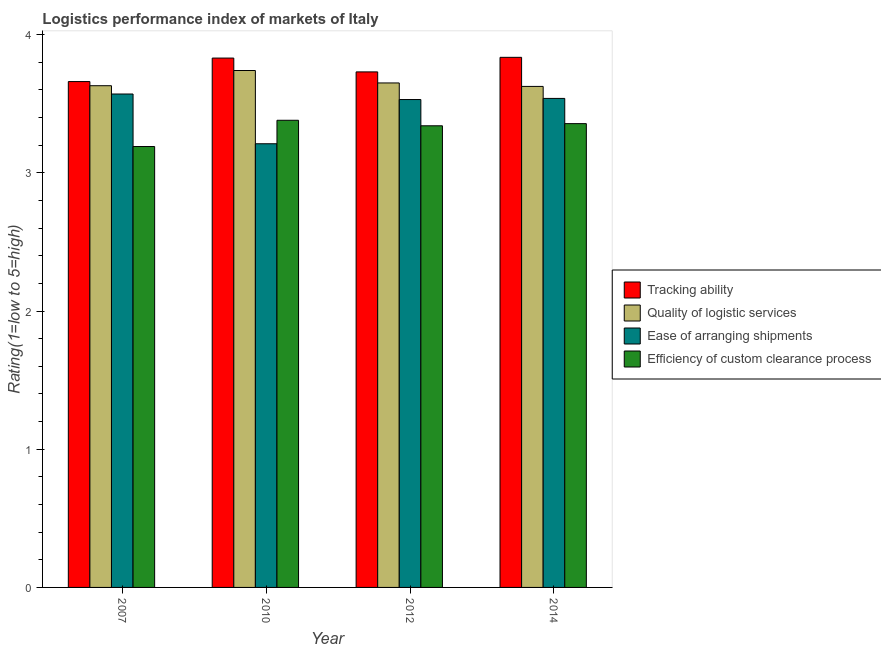Are the number of bars on each tick of the X-axis equal?
Offer a terse response. Yes. What is the lpi rating of efficiency of custom clearance process in 2010?
Keep it short and to the point. 3.38. Across all years, what is the maximum lpi rating of efficiency of custom clearance process?
Provide a short and direct response. 3.38. Across all years, what is the minimum lpi rating of efficiency of custom clearance process?
Offer a very short reply. 3.19. In which year was the lpi rating of ease of arranging shipments maximum?
Keep it short and to the point. 2007. What is the total lpi rating of quality of logistic services in the graph?
Give a very brief answer. 14.64. What is the difference between the lpi rating of quality of logistic services in 2007 and that in 2012?
Your answer should be compact. -0.02. What is the difference between the lpi rating of tracking ability in 2010 and the lpi rating of ease of arranging shipments in 2007?
Provide a succinct answer. 0.17. What is the average lpi rating of ease of arranging shipments per year?
Offer a very short reply. 3.46. In the year 2012, what is the difference between the lpi rating of quality of logistic services and lpi rating of ease of arranging shipments?
Offer a very short reply. 0. What is the ratio of the lpi rating of ease of arranging shipments in 2012 to that in 2014?
Your response must be concise. 1. Is the lpi rating of efficiency of custom clearance process in 2007 less than that in 2012?
Make the answer very short. Yes. What is the difference between the highest and the second highest lpi rating of ease of arranging shipments?
Give a very brief answer. 0.03. What is the difference between the highest and the lowest lpi rating of quality of logistic services?
Your answer should be compact. 0.12. In how many years, is the lpi rating of ease of arranging shipments greater than the average lpi rating of ease of arranging shipments taken over all years?
Give a very brief answer. 3. Is the sum of the lpi rating of ease of arranging shipments in 2007 and 2014 greater than the maximum lpi rating of tracking ability across all years?
Your response must be concise. Yes. What does the 3rd bar from the left in 2007 represents?
Give a very brief answer. Ease of arranging shipments. What does the 4th bar from the right in 2014 represents?
Ensure brevity in your answer.  Tracking ability. Is it the case that in every year, the sum of the lpi rating of tracking ability and lpi rating of quality of logistic services is greater than the lpi rating of ease of arranging shipments?
Keep it short and to the point. Yes. How many bars are there?
Your response must be concise. 16. Are the values on the major ticks of Y-axis written in scientific E-notation?
Give a very brief answer. No. Does the graph contain grids?
Offer a terse response. No. How many legend labels are there?
Your response must be concise. 4. What is the title of the graph?
Provide a succinct answer. Logistics performance index of markets of Italy. What is the label or title of the X-axis?
Your answer should be compact. Year. What is the label or title of the Y-axis?
Offer a very short reply. Rating(1=low to 5=high). What is the Rating(1=low to 5=high) in Tracking ability in 2007?
Give a very brief answer. 3.66. What is the Rating(1=low to 5=high) of Quality of logistic services in 2007?
Offer a very short reply. 3.63. What is the Rating(1=low to 5=high) of Ease of arranging shipments in 2007?
Your response must be concise. 3.57. What is the Rating(1=low to 5=high) of Efficiency of custom clearance process in 2007?
Keep it short and to the point. 3.19. What is the Rating(1=low to 5=high) in Tracking ability in 2010?
Give a very brief answer. 3.83. What is the Rating(1=low to 5=high) of Quality of logistic services in 2010?
Make the answer very short. 3.74. What is the Rating(1=low to 5=high) of Ease of arranging shipments in 2010?
Ensure brevity in your answer.  3.21. What is the Rating(1=low to 5=high) of Efficiency of custom clearance process in 2010?
Keep it short and to the point. 3.38. What is the Rating(1=low to 5=high) of Tracking ability in 2012?
Offer a terse response. 3.73. What is the Rating(1=low to 5=high) of Quality of logistic services in 2012?
Provide a succinct answer. 3.65. What is the Rating(1=low to 5=high) in Ease of arranging shipments in 2012?
Your answer should be very brief. 3.53. What is the Rating(1=low to 5=high) of Efficiency of custom clearance process in 2012?
Offer a very short reply. 3.34. What is the Rating(1=low to 5=high) in Tracking ability in 2014?
Your answer should be compact. 3.84. What is the Rating(1=low to 5=high) of Quality of logistic services in 2014?
Keep it short and to the point. 3.62. What is the Rating(1=low to 5=high) of Ease of arranging shipments in 2014?
Give a very brief answer. 3.54. What is the Rating(1=low to 5=high) in Efficiency of custom clearance process in 2014?
Give a very brief answer. 3.36. Across all years, what is the maximum Rating(1=low to 5=high) in Tracking ability?
Provide a succinct answer. 3.84. Across all years, what is the maximum Rating(1=low to 5=high) in Quality of logistic services?
Your response must be concise. 3.74. Across all years, what is the maximum Rating(1=low to 5=high) of Ease of arranging shipments?
Ensure brevity in your answer.  3.57. Across all years, what is the maximum Rating(1=low to 5=high) in Efficiency of custom clearance process?
Your answer should be compact. 3.38. Across all years, what is the minimum Rating(1=low to 5=high) of Tracking ability?
Provide a succinct answer. 3.66. Across all years, what is the minimum Rating(1=low to 5=high) in Quality of logistic services?
Your answer should be compact. 3.62. Across all years, what is the minimum Rating(1=low to 5=high) in Ease of arranging shipments?
Offer a very short reply. 3.21. Across all years, what is the minimum Rating(1=low to 5=high) of Efficiency of custom clearance process?
Your response must be concise. 3.19. What is the total Rating(1=low to 5=high) of Tracking ability in the graph?
Ensure brevity in your answer.  15.06. What is the total Rating(1=low to 5=high) of Quality of logistic services in the graph?
Keep it short and to the point. 14.64. What is the total Rating(1=low to 5=high) of Ease of arranging shipments in the graph?
Your answer should be very brief. 13.85. What is the total Rating(1=low to 5=high) of Efficiency of custom clearance process in the graph?
Provide a succinct answer. 13.27. What is the difference between the Rating(1=low to 5=high) in Tracking ability in 2007 and that in 2010?
Ensure brevity in your answer.  -0.17. What is the difference between the Rating(1=low to 5=high) in Quality of logistic services in 2007 and that in 2010?
Provide a succinct answer. -0.11. What is the difference between the Rating(1=low to 5=high) in Ease of arranging shipments in 2007 and that in 2010?
Your answer should be compact. 0.36. What is the difference between the Rating(1=low to 5=high) in Efficiency of custom clearance process in 2007 and that in 2010?
Your answer should be compact. -0.19. What is the difference between the Rating(1=low to 5=high) in Tracking ability in 2007 and that in 2012?
Your response must be concise. -0.07. What is the difference between the Rating(1=low to 5=high) of Quality of logistic services in 2007 and that in 2012?
Ensure brevity in your answer.  -0.02. What is the difference between the Rating(1=low to 5=high) in Ease of arranging shipments in 2007 and that in 2012?
Keep it short and to the point. 0.04. What is the difference between the Rating(1=low to 5=high) of Tracking ability in 2007 and that in 2014?
Make the answer very short. -0.18. What is the difference between the Rating(1=low to 5=high) of Quality of logistic services in 2007 and that in 2014?
Your answer should be very brief. 0.01. What is the difference between the Rating(1=low to 5=high) of Ease of arranging shipments in 2007 and that in 2014?
Give a very brief answer. 0.03. What is the difference between the Rating(1=low to 5=high) in Efficiency of custom clearance process in 2007 and that in 2014?
Offer a very short reply. -0.17. What is the difference between the Rating(1=low to 5=high) of Tracking ability in 2010 and that in 2012?
Offer a terse response. 0.1. What is the difference between the Rating(1=low to 5=high) of Quality of logistic services in 2010 and that in 2012?
Your answer should be compact. 0.09. What is the difference between the Rating(1=low to 5=high) of Ease of arranging shipments in 2010 and that in 2012?
Make the answer very short. -0.32. What is the difference between the Rating(1=low to 5=high) in Tracking ability in 2010 and that in 2014?
Give a very brief answer. -0.01. What is the difference between the Rating(1=low to 5=high) of Quality of logistic services in 2010 and that in 2014?
Offer a terse response. 0.12. What is the difference between the Rating(1=low to 5=high) in Ease of arranging shipments in 2010 and that in 2014?
Give a very brief answer. -0.33. What is the difference between the Rating(1=low to 5=high) in Efficiency of custom clearance process in 2010 and that in 2014?
Your answer should be compact. 0.02. What is the difference between the Rating(1=low to 5=high) in Tracking ability in 2012 and that in 2014?
Offer a very short reply. -0.11. What is the difference between the Rating(1=low to 5=high) of Quality of logistic services in 2012 and that in 2014?
Your response must be concise. 0.03. What is the difference between the Rating(1=low to 5=high) in Ease of arranging shipments in 2012 and that in 2014?
Make the answer very short. -0.01. What is the difference between the Rating(1=low to 5=high) of Efficiency of custom clearance process in 2012 and that in 2014?
Give a very brief answer. -0.02. What is the difference between the Rating(1=low to 5=high) in Tracking ability in 2007 and the Rating(1=low to 5=high) in Quality of logistic services in 2010?
Your response must be concise. -0.08. What is the difference between the Rating(1=low to 5=high) of Tracking ability in 2007 and the Rating(1=low to 5=high) of Ease of arranging shipments in 2010?
Your answer should be compact. 0.45. What is the difference between the Rating(1=low to 5=high) in Tracking ability in 2007 and the Rating(1=low to 5=high) in Efficiency of custom clearance process in 2010?
Provide a succinct answer. 0.28. What is the difference between the Rating(1=low to 5=high) of Quality of logistic services in 2007 and the Rating(1=low to 5=high) of Ease of arranging shipments in 2010?
Make the answer very short. 0.42. What is the difference between the Rating(1=low to 5=high) of Quality of logistic services in 2007 and the Rating(1=low to 5=high) of Efficiency of custom clearance process in 2010?
Give a very brief answer. 0.25. What is the difference between the Rating(1=low to 5=high) of Ease of arranging shipments in 2007 and the Rating(1=low to 5=high) of Efficiency of custom clearance process in 2010?
Your answer should be compact. 0.19. What is the difference between the Rating(1=low to 5=high) in Tracking ability in 2007 and the Rating(1=low to 5=high) in Ease of arranging shipments in 2012?
Provide a short and direct response. 0.13. What is the difference between the Rating(1=low to 5=high) of Tracking ability in 2007 and the Rating(1=low to 5=high) of Efficiency of custom clearance process in 2012?
Offer a very short reply. 0.32. What is the difference between the Rating(1=low to 5=high) in Quality of logistic services in 2007 and the Rating(1=low to 5=high) in Ease of arranging shipments in 2012?
Ensure brevity in your answer.  0.1. What is the difference between the Rating(1=low to 5=high) of Quality of logistic services in 2007 and the Rating(1=low to 5=high) of Efficiency of custom clearance process in 2012?
Ensure brevity in your answer.  0.29. What is the difference between the Rating(1=low to 5=high) of Ease of arranging shipments in 2007 and the Rating(1=low to 5=high) of Efficiency of custom clearance process in 2012?
Make the answer very short. 0.23. What is the difference between the Rating(1=low to 5=high) in Tracking ability in 2007 and the Rating(1=low to 5=high) in Quality of logistic services in 2014?
Your response must be concise. 0.04. What is the difference between the Rating(1=low to 5=high) of Tracking ability in 2007 and the Rating(1=low to 5=high) of Ease of arranging shipments in 2014?
Offer a terse response. 0.12. What is the difference between the Rating(1=low to 5=high) in Tracking ability in 2007 and the Rating(1=low to 5=high) in Efficiency of custom clearance process in 2014?
Provide a short and direct response. 0.3. What is the difference between the Rating(1=low to 5=high) of Quality of logistic services in 2007 and the Rating(1=low to 5=high) of Ease of arranging shipments in 2014?
Keep it short and to the point. 0.09. What is the difference between the Rating(1=low to 5=high) of Quality of logistic services in 2007 and the Rating(1=low to 5=high) of Efficiency of custom clearance process in 2014?
Keep it short and to the point. 0.27. What is the difference between the Rating(1=low to 5=high) in Ease of arranging shipments in 2007 and the Rating(1=low to 5=high) in Efficiency of custom clearance process in 2014?
Your response must be concise. 0.21. What is the difference between the Rating(1=low to 5=high) in Tracking ability in 2010 and the Rating(1=low to 5=high) in Quality of logistic services in 2012?
Offer a terse response. 0.18. What is the difference between the Rating(1=low to 5=high) in Tracking ability in 2010 and the Rating(1=low to 5=high) in Efficiency of custom clearance process in 2012?
Give a very brief answer. 0.49. What is the difference between the Rating(1=low to 5=high) of Quality of logistic services in 2010 and the Rating(1=low to 5=high) of Ease of arranging shipments in 2012?
Make the answer very short. 0.21. What is the difference between the Rating(1=low to 5=high) in Ease of arranging shipments in 2010 and the Rating(1=low to 5=high) in Efficiency of custom clearance process in 2012?
Your answer should be very brief. -0.13. What is the difference between the Rating(1=low to 5=high) in Tracking ability in 2010 and the Rating(1=low to 5=high) in Quality of logistic services in 2014?
Offer a terse response. 0.2. What is the difference between the Rating(1=low to 5=high) in Tracking ability in 2010 and the Rating(1=low to 5=high) in Ease of arranging shipments in 2014?
Your response must be concise. 0.29. What is the difference between the Rating(1=low to 5=high) of Tracking ability in 2010 and the Rating(1=low to 5=high) of Efficiency of custom clearance process in 2014?
Your answer should be compact. 0.47. What is the difference between the Rating(1=low to 5=high) in Quality of logistic services in 2010 and the Rating(1=low to 5=high) in Ease of arranging shipments in 2014?
Your response must be concise. 0.2. What is the difference between the Rating(1=low to 5=high) of Quality of logistic services in 2010 and the Rating(1=low to 5=high) of Efficiency of custom clearance process in 2014?
Your answer should be compact. 0.38. What is the difference between the Rating(1=low to 5=high) in Ease of arranging shipments in 2010 and the Rating(1=low to 5=high) in Efficiency of custom clearance process in 2014?
Your response must be concise. -0.15. What is the difference between the Rating(1=low to 5=high) of Tracking ability in 2012 and the Rating(1=low to 5=high) of Quality of logistic services in 2014?
Give a very brief answer. 0.1. What is the difference between the Rating(1=low to 5=high) in Tracking ability in 2012 and the Rating(1=low to 5=high) in Ease of arranging shipments in 2014?
Offer a very short reply. 0.19. What is the difference between the Rating(1=low to 5=high) of Tracking ability in 2012 and the Rating(1=low to 5=high) of Efficiency of custom clearance process in 2014?
Make the answer very short. 0.37. What is the difference between the Rating(1=low to 5=high) in Quality of logistic services in 2012 and the Rating(1=low to 5=high) in Ease of arranging shipments in 2014?
Provide a succinct answer. 0.11. What is the difference between the Rating(1=low to 5=high) of Quality of logistic services in 2012 and the Rating(1=low to 5=high) of Efficiency of custom clearance process in 2014?
Your answer should be very brief. 0.29. What is the difference between the Rating(1=low to 5=high) of Ease of arranging shipments in 2012 and the Rating(1=low to 5=high) of Efficiency of custom clearance process in 2014?
Offer a terse response. 0.17. What is the average Rating(1=low to 5=high) of Tracking ability per year?
Your response must be concise. 3.76. What is the average Rating(1=low to 5=high) of Quality of logistic services per year?
Offer a very short reply. 3.66. What is the average Rating(1=low to 5=high) in Ease of arranging shipments per year?
Provide a short and direct response. 3.46. What is the average Rating(1=low to 5=high) in Efficiency of custom clearance process per year?
Provide a succinct answer. 3.32. In the year 2007, what is the difference between the Rating(1=low to 5=high) of Tracking ability and Rating(1=low to 5=high) of Quality of logistic services?
Offer a terse response. 0.03. In the year 2007, what is the difference between the Rating(1=low to 5=high) in Tracking ability and Rating(1=low to 5=high) in Ease of arranging shipments?
Your answer should be compact. 0.09. In the year 2007, what is the difference between the Rating(1=low to 5=high) of Tracking ability and Rating(1=low to 5=high) of Efficiency of custom clearance process?
Your answer should be compact. 0.47. In the year 2007, what is the difference between the Rating(1=low to 5=high) of Quality of logistic services and Rating(1=low to 5=high) of Ease of arranging shipments?
Provide a short and direct response. 0.06. In the year 2007, what is the difference between the Rating(1=low to 5=high) in Quality of logistic services and Rating(1=low to 5=high) in Efficiency of custom clearance process?
Offer a terse response. 0.44. In the year 2007, what is the difference between the Rating(1=low to 5=high) of Ease of arranging shipments and Rating(1=low to 5=high) of Efficiency of custom clearance process?
Your answer should be very brief. 0.38. In the year 2010, what is the difference between the Rating(1=low to 5=high) in Tracking ability and Rating(1=low to 5=high) in Quality of logistic services?
Provide a short and direct response. 0.09. In the year 2010, what is the difference between the Rating(1=low to 5=high) of Tracking ability and Rating(1=low to 5=high) of Ease of arranging shipments?
Your response must be concise. 0.62. In the year 2010, what is the difference between the Rating(1=low to 5=high) in Tracking ability and Rating(1=low to 5=high) in Efficiency of custom clearance process?
Your answer should be very brief. 0.45. In the year 2010, what is the difference between the Rating(1=low to 5=high) of Quality of logistic services and Rating(1=low to 5=high) of Ease of arranging shipments?
Keep it short and to the point. 0.53. In the year 2010, what is the difference between the Rating(1=low to 5=high) in Quality of logistic services and Rating(1=low to 5=high) in Efficiency of custom clearance process?
Ensure brevity in your answer.  0.36. In the year 2010, what is the difference between the Rating(1=low to 5=high) of Ease of arranging shipments and Rating(1=low to 5=high) of Efficiency of custom clearance process?
Your answer should be compact. -0.17. In the year 2012, what is the difference between the Rating(1=low to 5=high) of Tracking ability and Rating(1=low to 5=high) of Efficiency of custom clearance process?
Your answer should be compact. 0.39. In the year 2012, what is the difference between the Rating(1=low to 5=high) of Quality of logistic services and Rating(1=low to 5=high) of Ease of arranging shipments?
Keep it short and to the point. 0.12. In the year 2012, what is the difference between the Rating(1=low to 5=high) of Quality of logistic services and Rating(1=low to 5=high) of Efficiency of custom clearance process?
Your answer should be very brief. 0.31. In the year 2012, what is the difference between the Rating(1=low to 5=high) in Ease of arranging shipments and Rating(1=low to 5=high) in Efficiency of custom clearance process?
Provide a succinct answer. 0.19. In the year 2014, what is the difference between the Rating(1=low to 5=high) of Tracking ability and Rating(1=low to 5=high) of Quality of logistic services?
Your answer should be compact. 0.21. In the year 2014, what is the difference between the Rating(1=low to 5=high) in Tracking ability and Rating(1=low to 5=high) in Ease of arranging shipments?
Your response must be concise. 0.3. In the year 2014, what is the difference between the Rating(1=low to 5=high) in Tracking ability and Rating(1=low to 5=high) in Efficiency of custom clearance process?
Your answer should be compact. 0.48. In the year 2014, what is the difference between the Rating(1=low to 5=high) in Quality of logistic services and Rating(1=low to 5=high) in Ease of arranging shipments?
Offer a very short reply. 0.09. In the year 2014, what is the difference between the Rating(1=low to 5=high) in Quality of logistic services and Rating(1=low to 5=high) in Efficiency of custom clearance process?
Ensure brevity in your answer.  0.27. In the year 2014, what is the difference between the Rating(1=low to 5=high) in Ease of arranging shipments and Rating(1=low to 5=high) in Efficiency of custom clearance process?
Your answer should be compact. 0.18. What is the ratio of the Rating(1=low to 5=high) of Tracking ability in 2007 to that in 2010?
Give a very brief answer. 0.96. What is the ratio of the Rating(1=low to 5=high) in Quality of logistic services in 2007 to that in 2010?
Make the answer very short. 0.97. What is the ratio of the Rating(1=low to 5=high) in Ease of arranging shipments in 2007 to that in 2010?
Provide a succinct answer. 1.11. What is the ratio of the Rating(1=low to 5=high) in Efficiency of custom clearance process in 2007 to that in 2010?
Offer a terse response. 0.94. What is the ratio of the Rating(1=low to 5=high) in Tracking ability in 2007 to that in 2012?
Offer a very short reply. 0.98. What is the ratio of the Rating(1=low to 5=high) of Ease of arranging shipments in 2007 to that in 2012?
Keep it short and to the point. 1.01. What is the ratio of the Rating(1=low to 5=high) in Efficiency of custom clearance process in 2007 to that in 2012?
Provide a succinct answer. 0.96. What is the ratio of the Rating(1=low to 5=high) of Tracking ability in 2007 to that in 2014?
Ensure brevity in your answer.  0.95. What is the ratio of the Rating(1=low to 5=high) in Quality of logistic services in 2007 to that in 2014?
Provide a short and direct response. 1. What is the ratio of the Rating(1=low to 5=high) of Efficiency of custom clearance process in 2007 to that in 2014?
Your answer should be compact. 0.95. What is the ratio of the Rating(1=low to 5=high) in Tracking ability in 2010 to that in 2012?
Ensure brevity in your answer.  1.03. What is the ratio of the Rating(1=low to 5=high) of Quality of logistic services in 2010 to that in 2012?
Ensure brevity in your answer.  1.02. What is the ratio of the Rating(1=low to 5=high) in Ease of arranging shipments in 2010 to that in 2012?
Your answer should be very brief. 0.91. What is the ratio of the Rating(1=low to 5=high) of Quality of logistic services in 2010 to that in 2014?
Keep it short and to the point. 1.03. What is the ratio of the Rating(1=low to 5=high) in Ease of arranging shipments in 2010 to that in 2014?
Your answer should be compact. 0.91. What is the ratio of the Rating(1=low to 5=high) of Efficiency of custom clearance process in 2010 to that in 2014?
Offer a terse response. 1.01. What is the ratio of the Rating(1=low to 5=high) of Tracking ability in 2012 to that in 2014?
Ensure brevity in your answer.  0.97. What is the ratio of the Rating(1=low to 5=high) of Ease of arranging shipments in 2012 to that in 2014?
Ensure brevity in your answer.  1. What is the ratio of the Rating(1=low to 5=high) of Efficiency of custom clearance process in 2012 to that in 2014?
Offer a very short reply. 1. What is the difference between the highest and the second highest Rating(1=low to 5=high) of Tracking ability?
Your answer should be compact. 0.01. What is the difference between the highest and the second highest Rating(1=low to 5=high) of Quality of logistic services?
Make the answer very short. 0.09. What is the difference between the highest and the second highest Rating(1=low to 5=high) of Ease of arranging shipments?
Provide a succinct answer. 0.03. What is the difference between the highest and the second highest Rating(1=low to 5=high) of Efficiency of custom clearance process?
Keep it short and to the point. 0.02. What is the difference between the highest and the lowest Rating(1=low to 5=high) in Tracking ability?
Your response must be concise. 0.18. What is the difference between the highest and the lowest Rating(1=low to 5=high) of Quality of logistic services?
Make the answer very short. 0.12. What is the difference between the highest and the lowest Rating(1=low to 5=high) of Ease of arranging shipments?
Ensure brevity in your answer.  0.36. What is the difference between the highest and the lowest Rating(1=low to 5=high) of Efficiency of custom clearance process?
Offer a terse response. 0.19. 